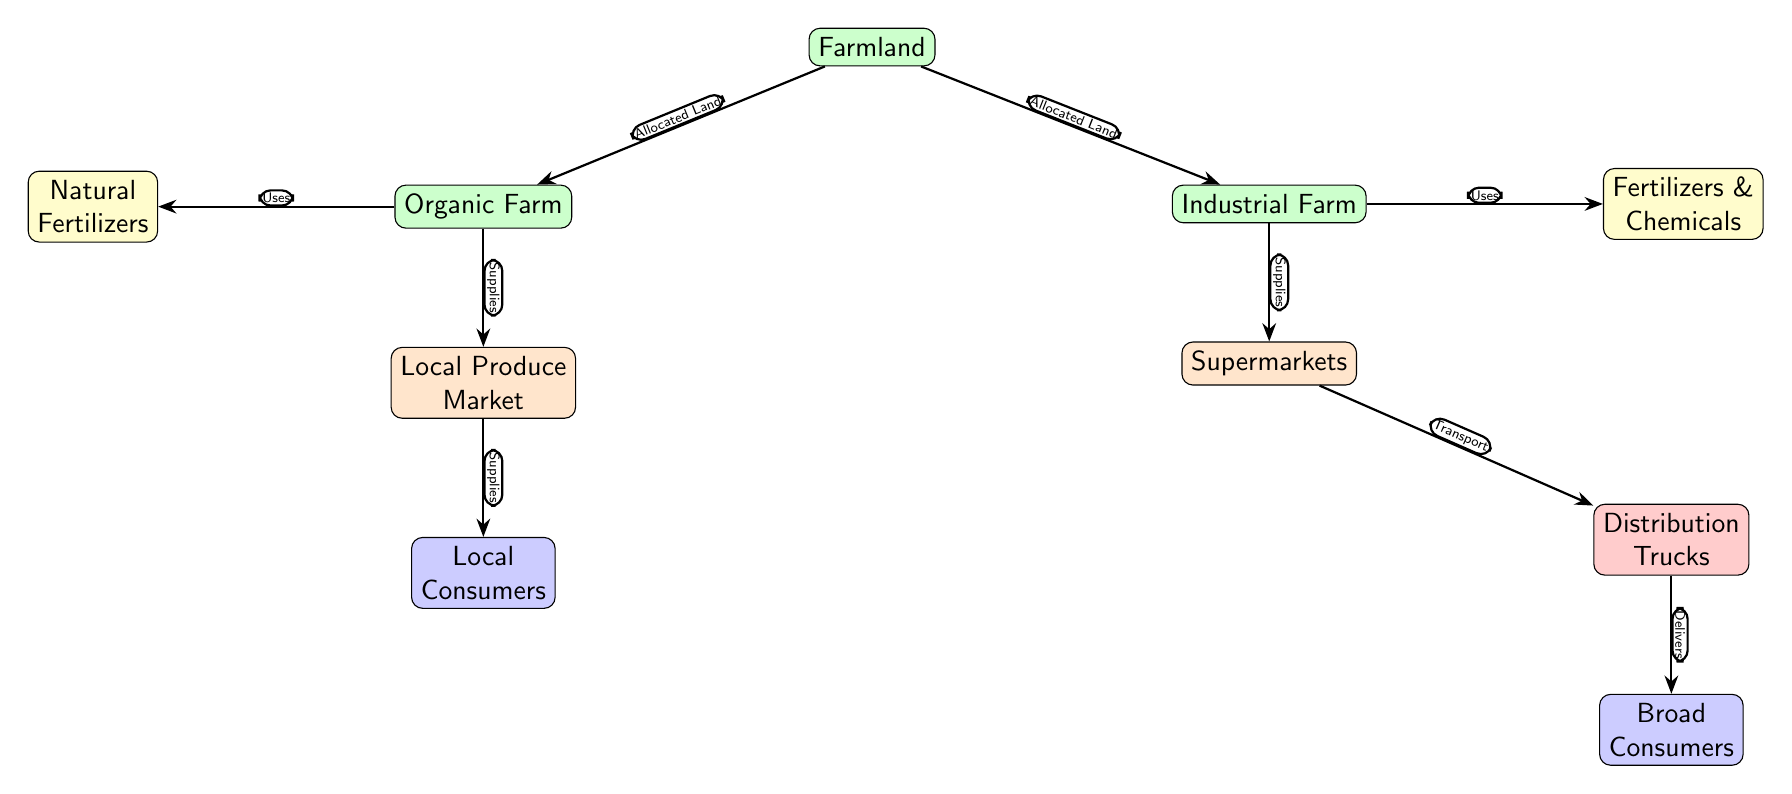What are the two types of farms shown in the diagram? The diagram explicitly labels two types of farms: Organic Farm and Industrial Farm, which are positioned below the Farmland node.
Answer: Organic Farm, Industrial Farm How many market nodes are present? The diagram includes two market nodes: Local Produce Market and Supermarkets, shown below their respective farm types.
Answer: 2 What type of fertilizers does the Organic Farm use? The diagram indicates that the Organic Farm uses Natural Fertilizers, as indicated by the edge connecting the Organic Farm to the Natural Fertilizers node.
Answer: Natural Fertilizers Who do the Supermarkets supply their products to? According to the diagram, Supermarkets supply their products to Broad Consumers, as shown by the edge pointing from Supermarkets to the Broad Consumers node.
Answer: Broad Consumers What is the relationship between the Organic Farm and the Local Produce Market? The diagram illustrates that the Organic Farm Supplies the Local Produce Market, indicated by the edge between these two nodes.
Answer: Supplies What flows from the Industrial Farm to the Supermarkets? The diagram shows that the Industrial Farm Supplies Supermarkets, which can be deduced from the edge labeled "Supplies" between these nodes.
Answer: Supplies Which farm type has a connection to Natural Fertilizers? The Organic Farm is shown to have a connection to Natural Fertilizers, as indicated in the diagram where the Organic Farm arrow points to the Natural Fertilizers node.
Answer: Organic Farm What type of consumers does the Local Produce Market serve? The diagram states that the Local Produce Market serves Local Consumers, found below the Local Produce Market node.
Answer: Local Consumers What do Distribution Trucks do in this chain? The diagram depicts that Distribution Trucks transport products from Supermarkets to Broad Consumers, reflected in the connecting edge labeled "Delivers."
Answer: Delivers 